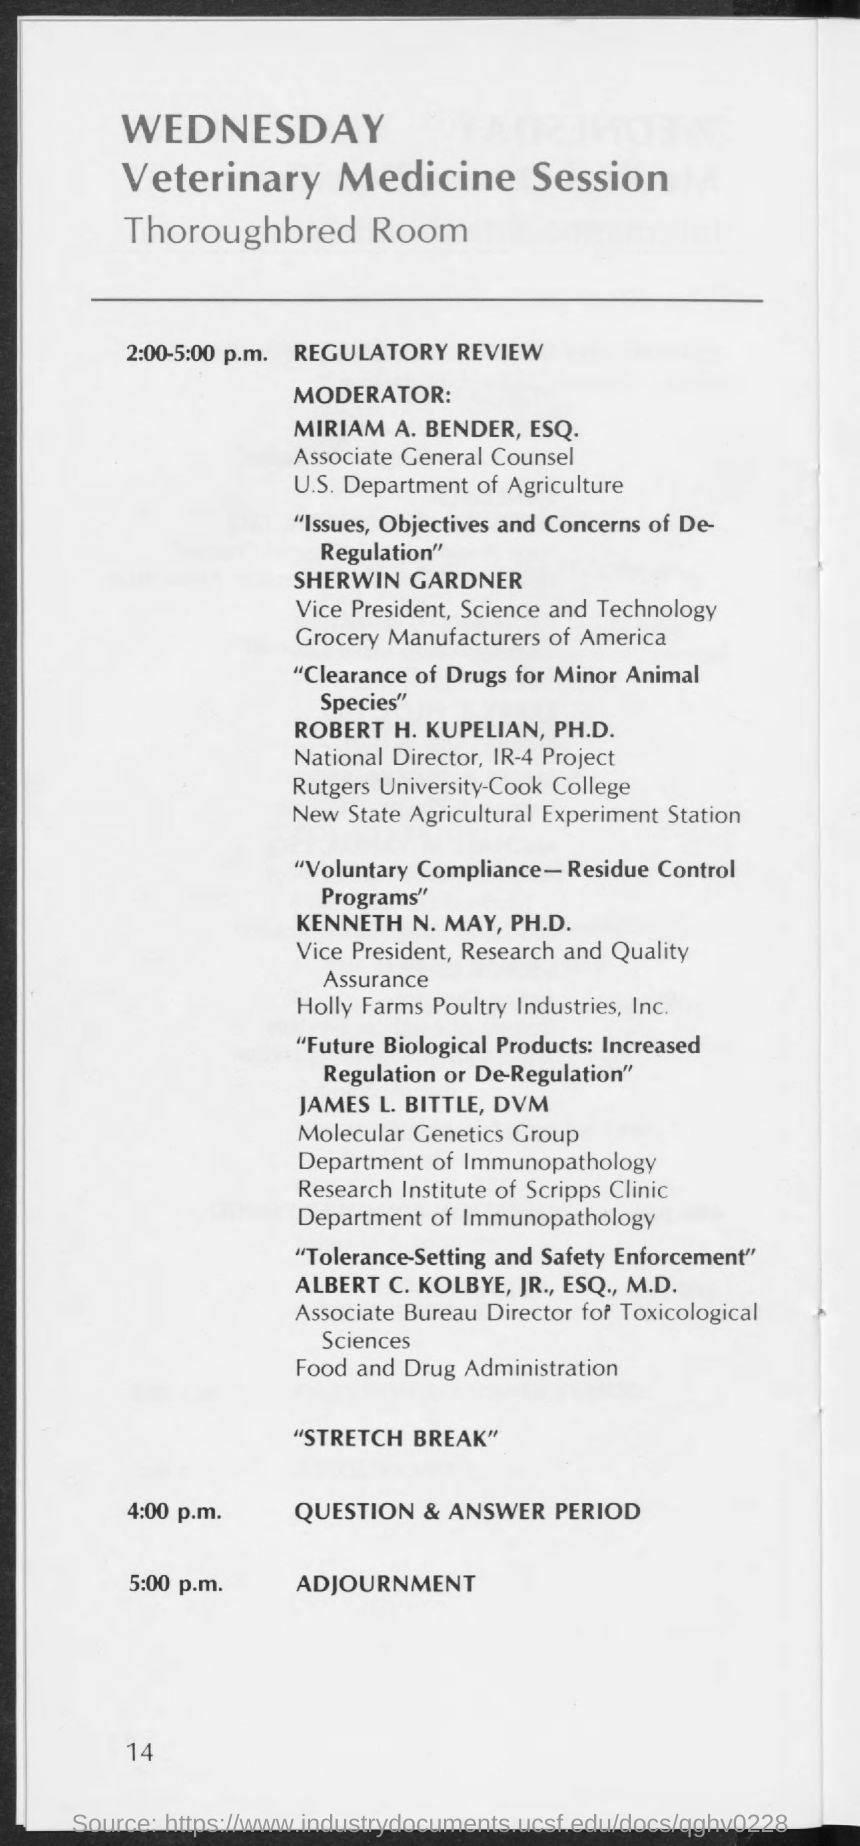List a handful of essential elements in this visual. The regulatory review will take place from 2:00-5:00 p.m. The question and answer period is scheduled for 4:00 PM. 